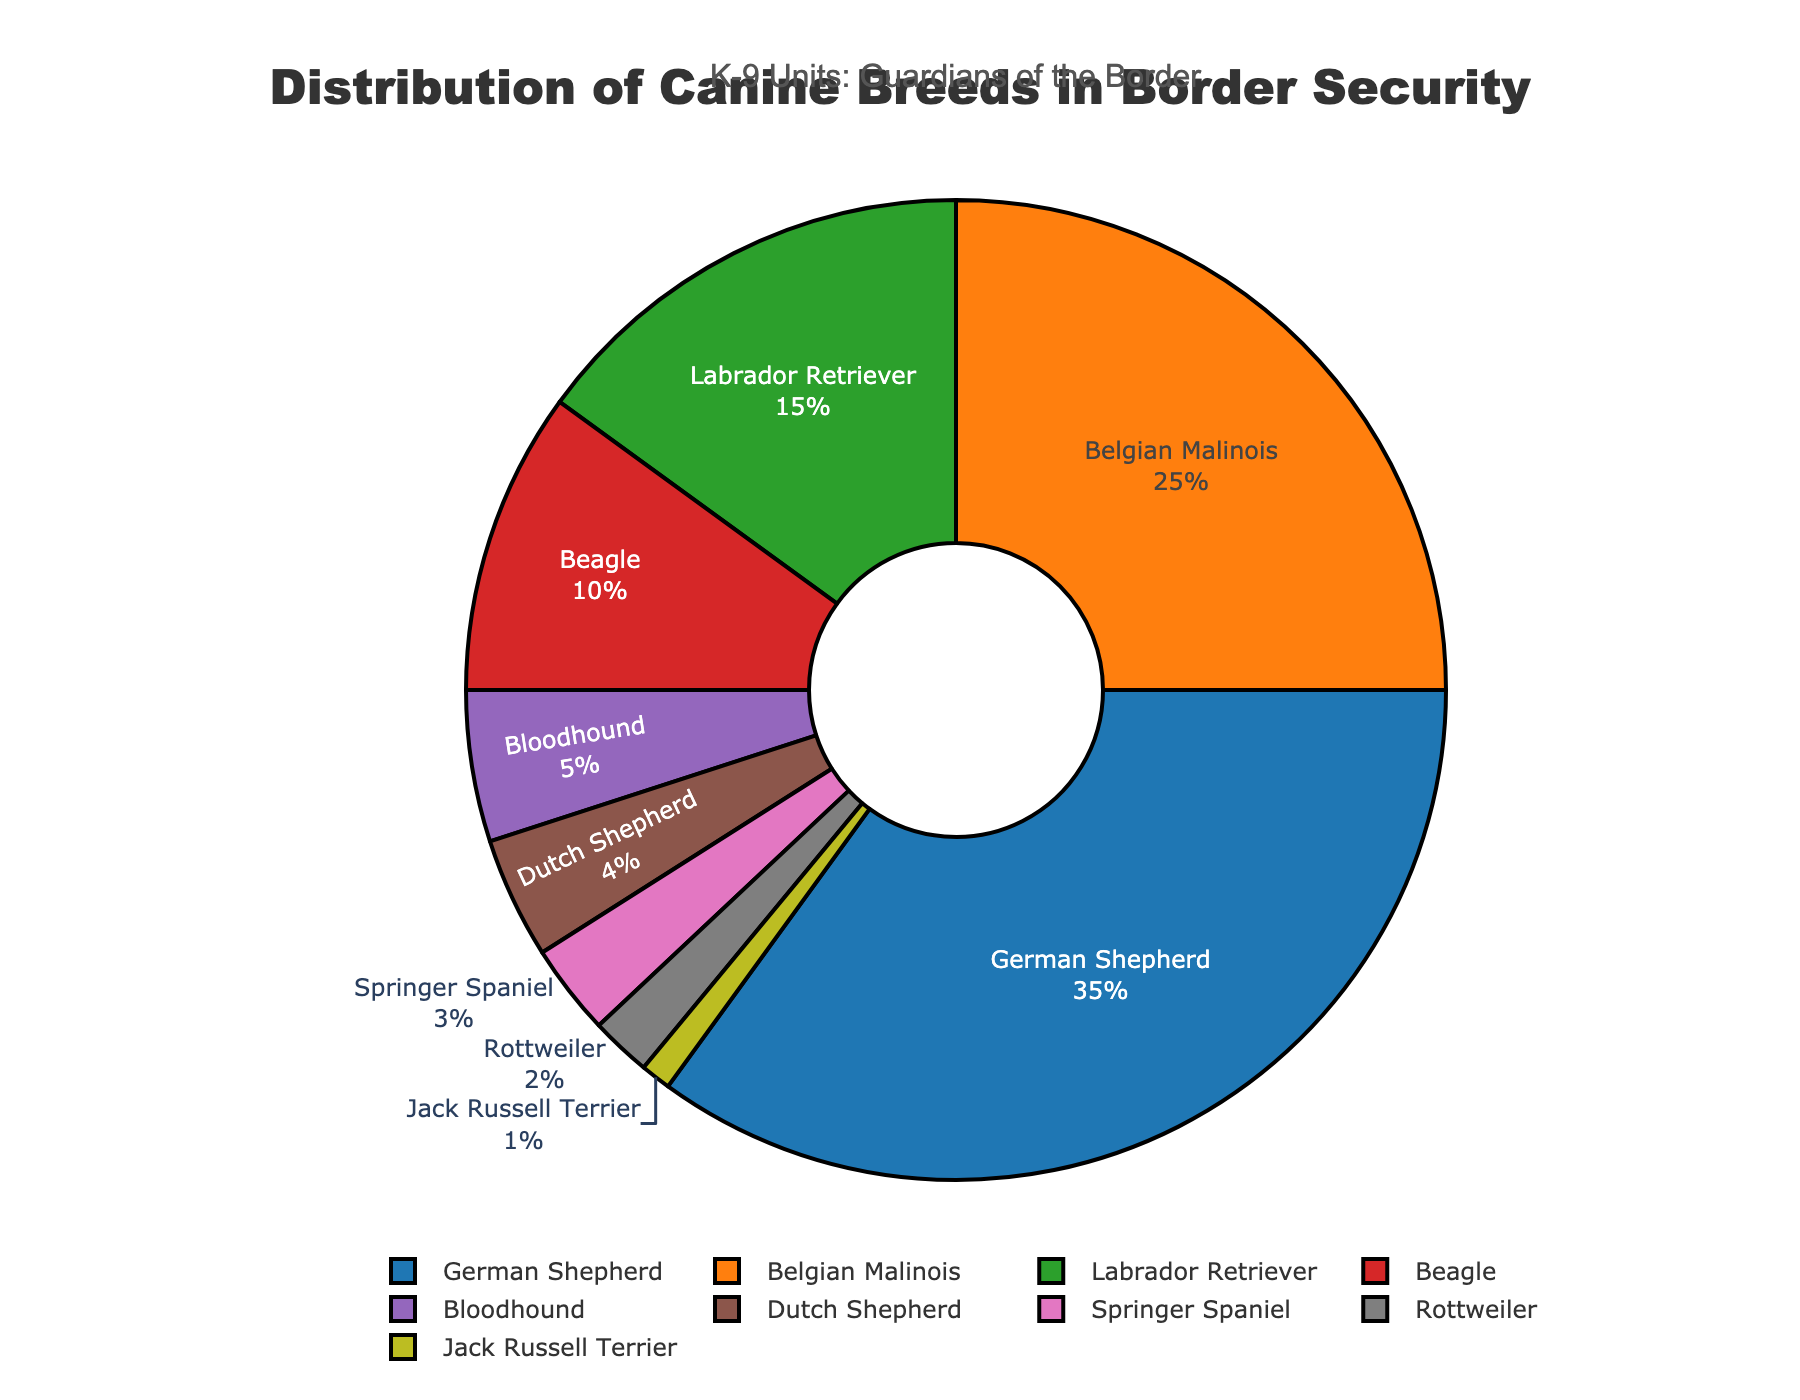What's the percentage of German Shepherds used in border security operations? The chart indicates the percentage of each canine breed. The German Shepherd has a section labeled with its percentage.
Answer: 35% Which breed has the smallest representation in border security operations? Observe the pie chart segments and their labels. The breed with the smallest percentage will have the smallest segment.
Answer: Jack Russell Terrier How much more percentage does the German Shepherd have compared to the Dutch Shepherd? The German Shepherd has 35%, and the Dutch Shepherd has 4%. Subtract the smaller percentage from the larger one: 35% - 4%.
Answer: 31% What is the combined percentage of Beagles and Bloodhounds? Identify the percentages for Beagle (10%) and Bloodhound (5%) in the chart and add them together: 10% + 5%.
Answer: 15% Which breed represents a quarter of the canine units used in border security? Look at the percentages on the chart. The Belgian Malinois corresponds to 25%, which is a quarter.
Answer: Belgian Malinois How does the percentage of Labrador Retrievers compare to that of Springer Spaniels? The Labrador Retriever's percentage is 15%, and Spring Spaniel is 3%. Check which value is larger and by how much: 15% is greater than 3%.
Answer: 15% is greater What's the difference in percentage between Beagles and Rottweilers? Beagle has 10%, and Rottweiler has 2%. Subtract the smaller percentage from the larger one: 10% - 2%.
Answer: 8% How many breeds have a percentage lower than 5%? Identify the slices of the chart which have percentages listed below 5%. There are three: Dutch Shepherd (4%), Springer Spaniel (3%), and Jack Russell Terrier (1%).
Answer: 3 breeds Can you list all the breeds that make up more than 20% each of the canine units? Look at the chart for breeds with greater than 20%. The German Shepherd (35%) and Belgian Malinois (25%) meet this criterion.
Answer: German Shepherd, Belgian Malinois 